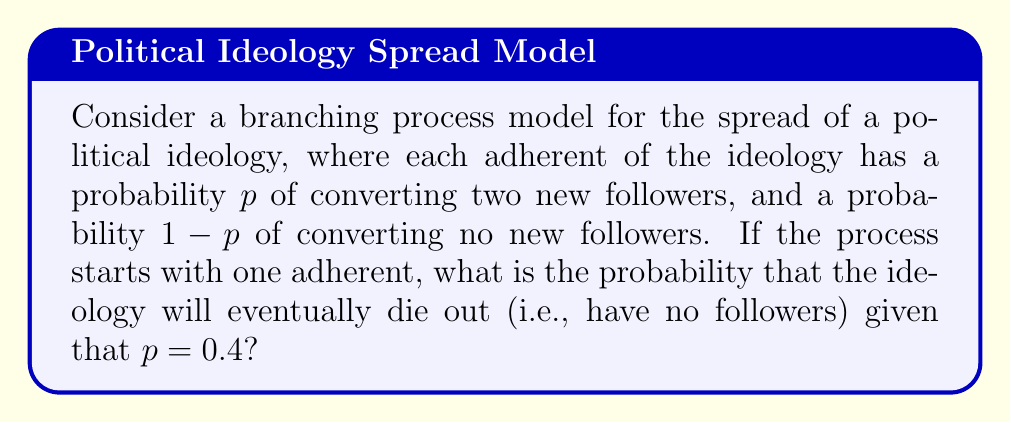Teach me how to tackle this problem. To solve this problem, we'll use the theory of branching processes:

1) Let $q$ be the probability that the ideology eventually dies out.

2) In a branching process, the extinction probability $q$ satisfies the equation:
   $q = f(q)$, where $f(s)$ is the probability generating function of the offspring distribution.

3) In this case, the probability generating function is:
   $f(s) = (1-p) + ps^2 = 0.6 + 0.4s^2$

4) So, we need to solve the equation:
   $q = 0.6 + 0.4q^2$

5) Rearranging:
   $0.4q^2 - q + 0.6 = 0$

6) This is a quadratic equation. We can solve it using the quadratic formula:
   $q = \frac{1 \pm \sqrt{1 - 4(0.4)(0.6)}}{2(0.4)}$

7) Simplifying:
   $q = \frac{1 \pm \sqrt{0.04}}{0.8} = \frac{1 \pm 0.2}{0.8}$

8) This gives us two solutions: $q = 1.5$ or $q = 0.75$

9) Since $q$ is a probability, it must be between 0 and 1. Therefore, $q = 0.75$ is the valid solution.
Answer: 0.75 